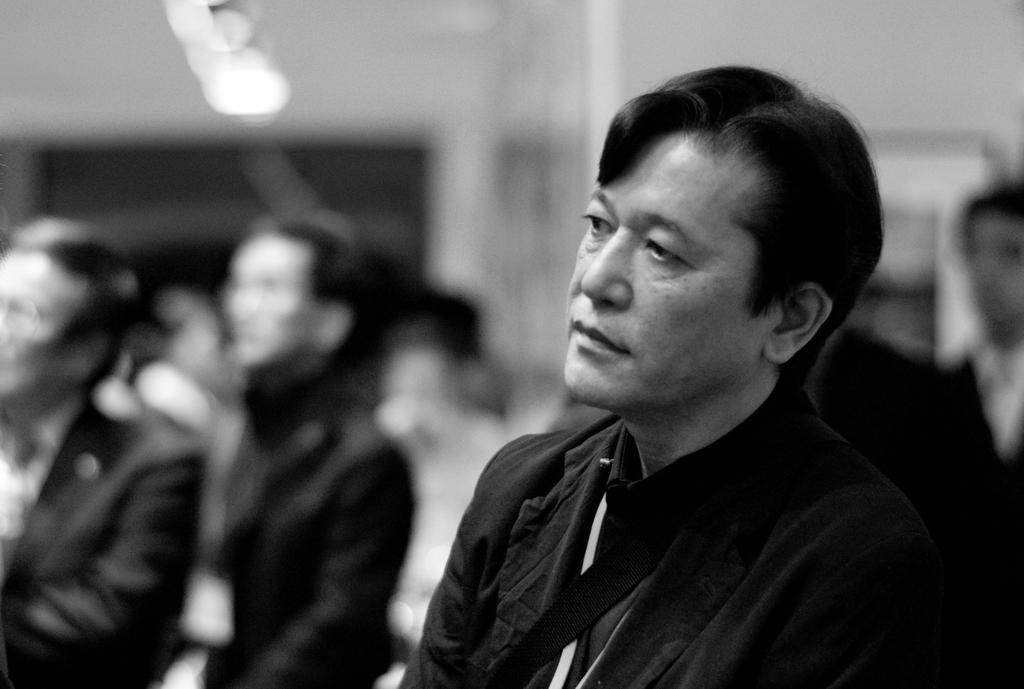What is the color scheme of the image? The image is black and white. What can be seen in the image? There are people in the image. What else is visible in the image besides the people? There are lights visible in the image. Can you describe the background of the image? The background of the image is blurred. How many frogs are sitting on the bulb in the image? There are no frogs or bulbs present in the image. What type of animal can be seen interacting with the people in the image? There are no animals visible in the image; only people and lights are present. 